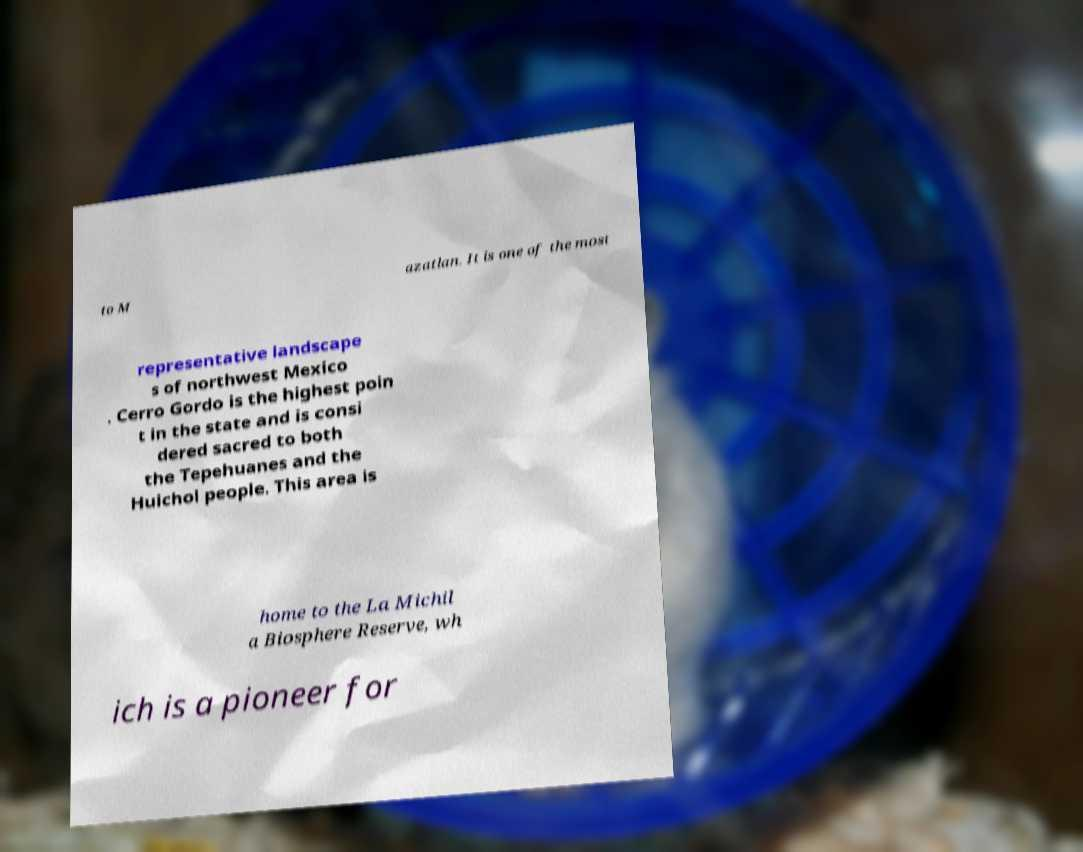Can you read and provide the text displayed in the image?This photo seems to have some interesting text. Can you extract and type it out for me? to M azatlan. It is one of the most representative landscape s of northwest Mexico . Cerro Gordo is the highest poin t in the state and is consi dered sacred to both the Tepehuanes and the Huichol people. This area is home to the La Michil a Biosphere Reserve, wh ich is a pioneer for 